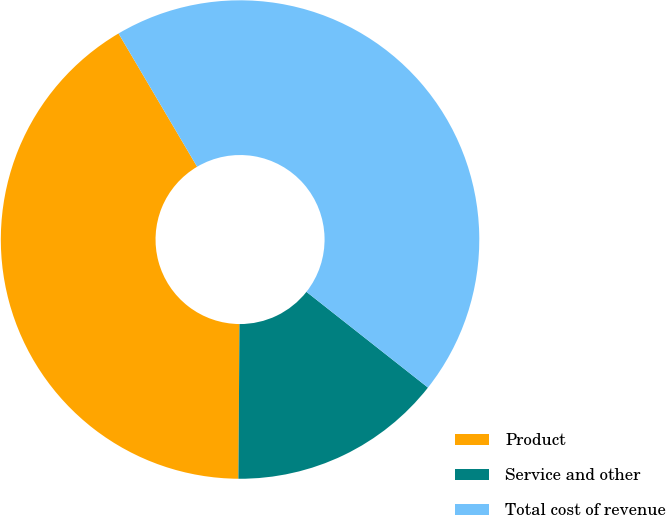<chart> <loc_0><loc_0><loc_500><loc_500><pie_chart><fcel>Product<fcel>Service and other<fcel>Total cost of revenue<nl><fcel>41.41%<fcel>14.49%<fcel>44.1%<nl></chart> 